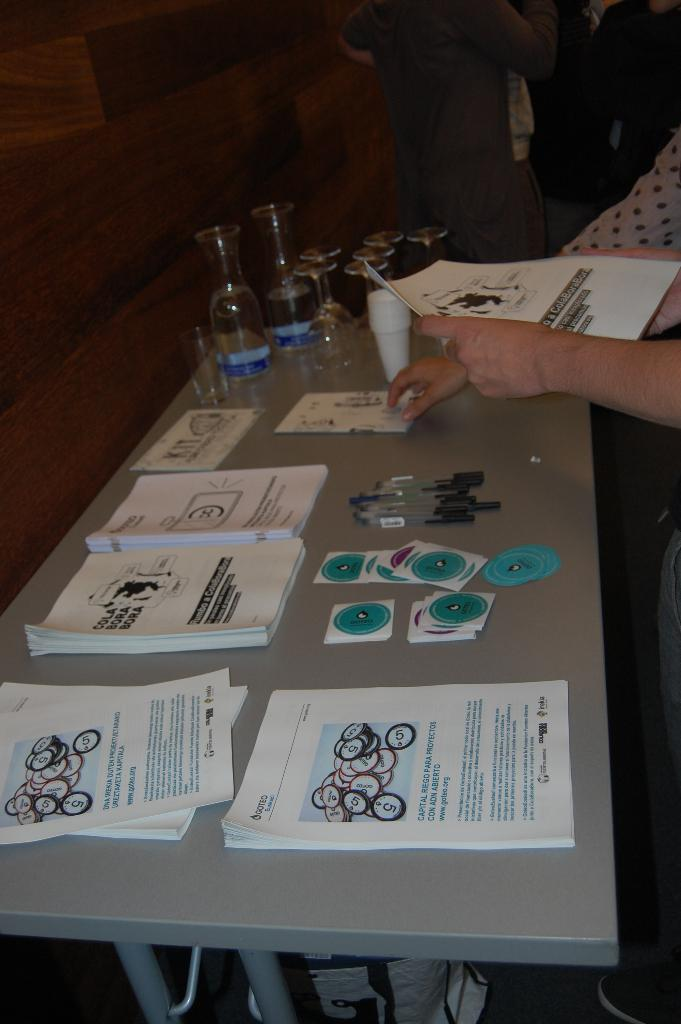What items can be seen on the table in the image? There are books, pens, and glasses on the table. Are there any other objects on the table besides the ones mentioned? Yes, there are other objects on the table. What might the persons standing around the table be doing? They might be discussing or working on something together. Can you describe the table setting in the image? The table has various objects on it, including books, pens, and glasses. What type of hill can be seen in the background of the image? There is no hill visible in the image; it features a table with various objects and persons standing around it. 